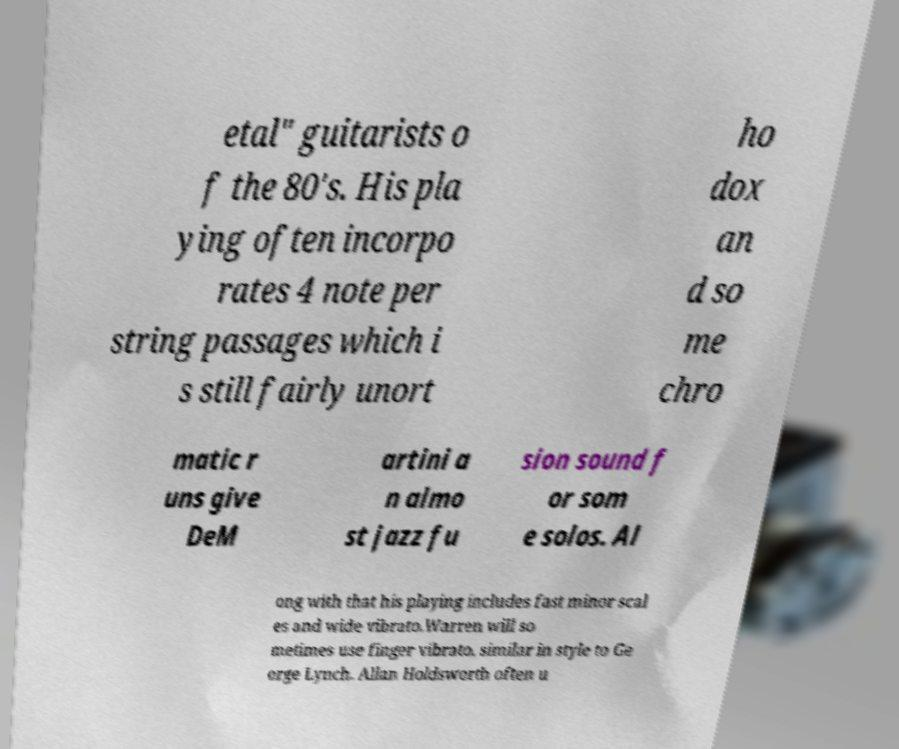Please identify and transcribe the text found in this image. etal" guitarists o f the 80's. His pla ying often incorpo rates 4 note per string passages which i s still fairly unort ho dox an d so me chro matic r uns give DeM artini a n almo st jazz fu sion sound f or som e solos. Al ong with that his playing includes fast minor scal es and wide vibrato.Warren will so metimes use finger vibrato, similar in style to Ge orge Lynch. Allan Holdsworth often u 